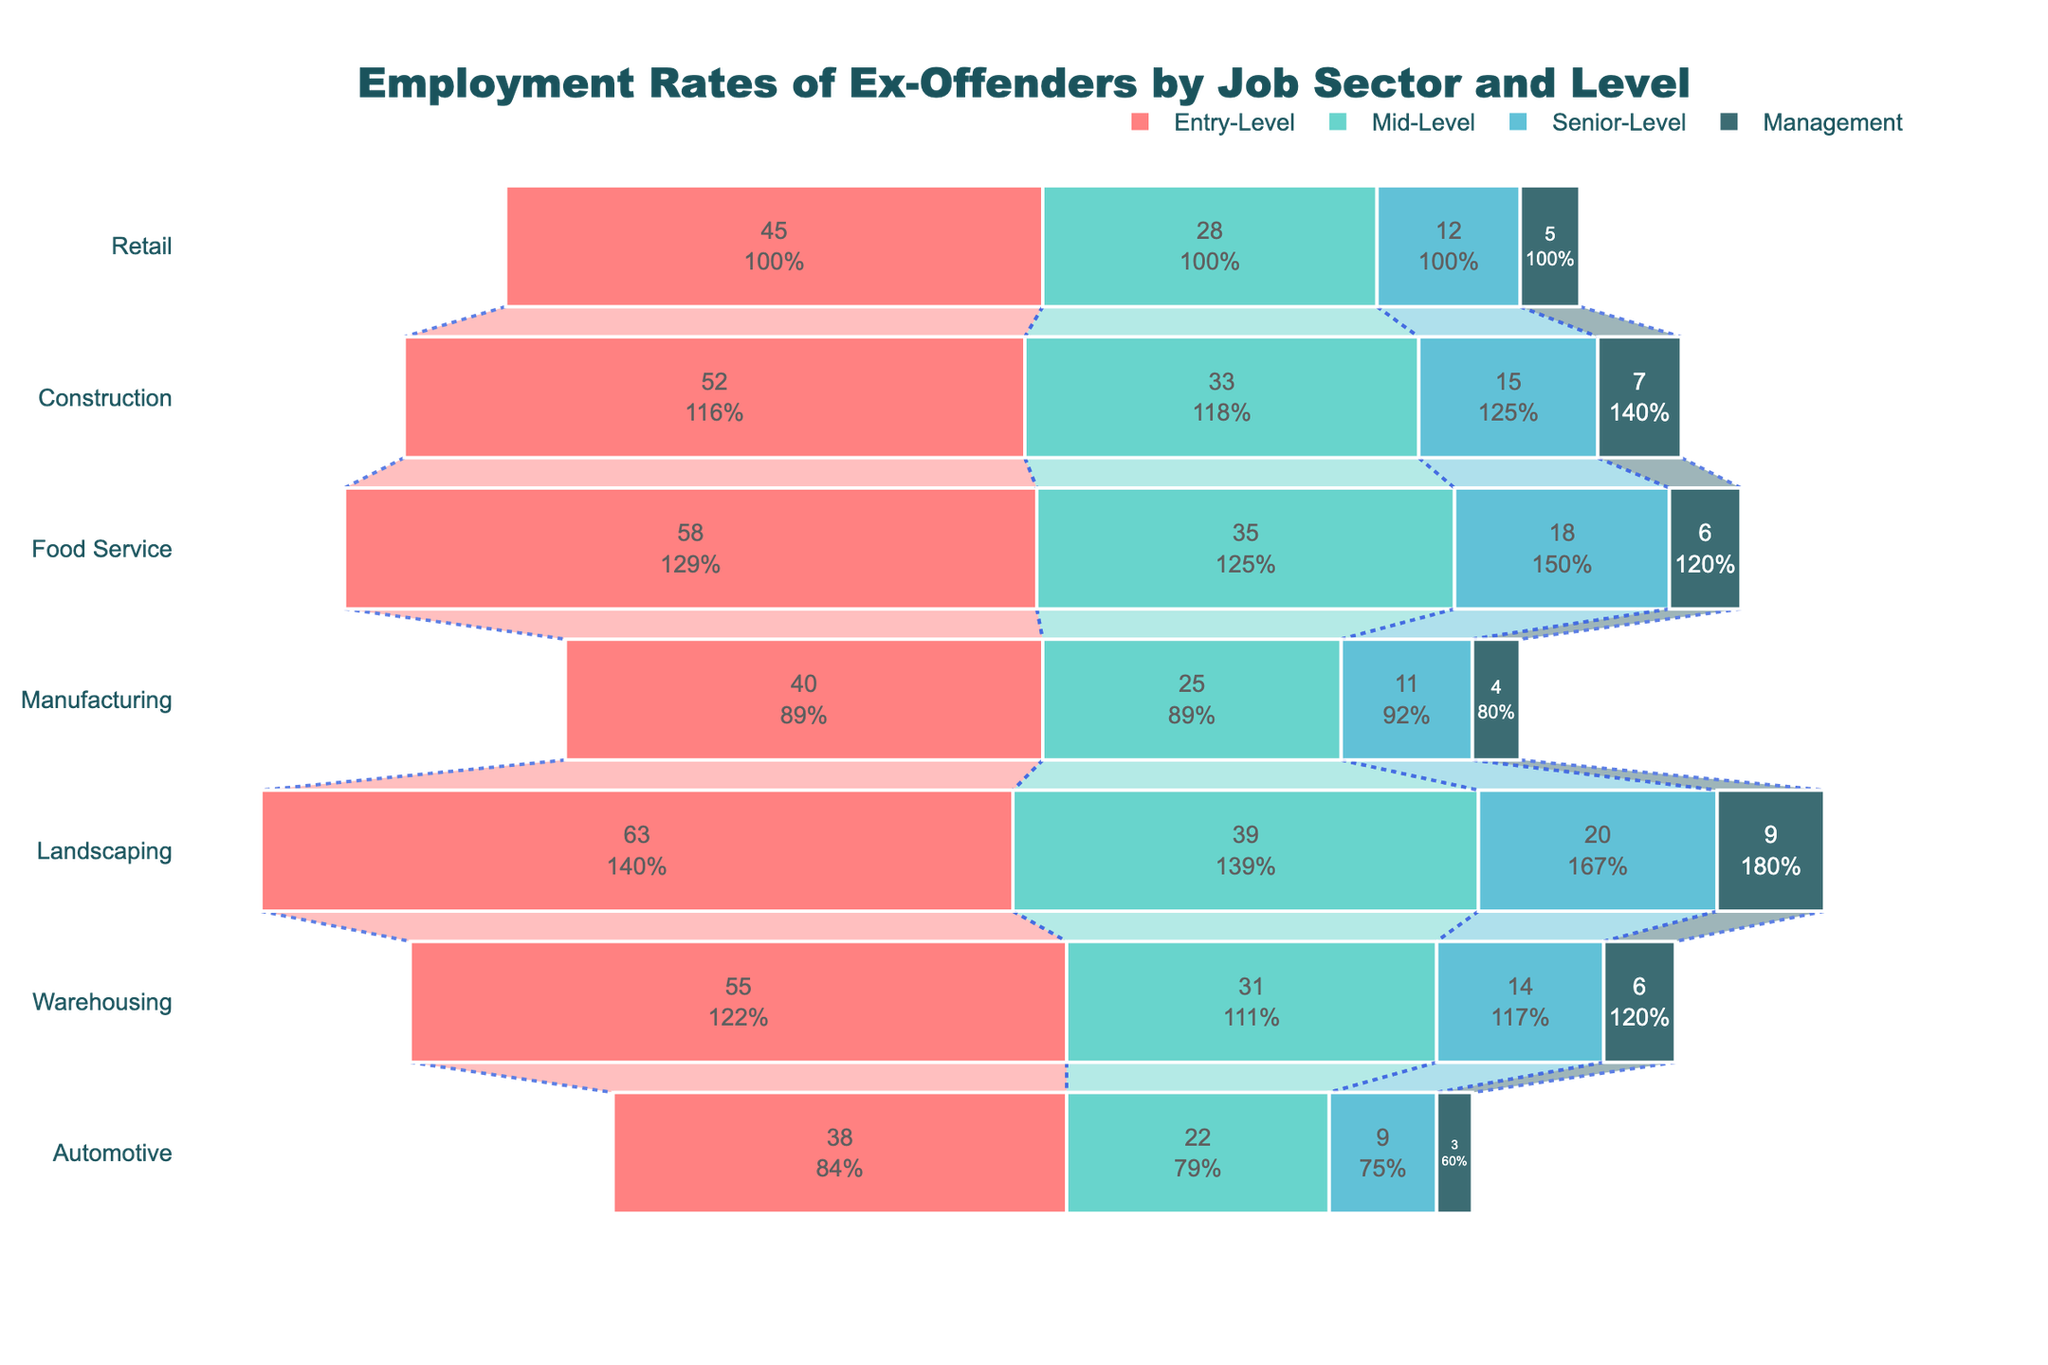What's the title of the figure? The title is typically displayed at the top center of the figure. In this case, the title is "Employment Rates of Ex-Offenders by Job Sector and Level."
Answer: Employment Rates of Ex-Offenders by Job Sector and Level How many job sectors are analyzed in the figure? The job sectors appear on the y-axis of the funnel chart. By counting them, we can see there are seven job sectors listed.
Answer: Seven Which job sector has the highest percentage of ex-offenders at the entry-level? By observing the bars at the "Entry-Level" section, the tallest bar corresponds to "Landscaping," which stands at 63%.
Answer: Landscaping Compare entry-level and management positions in the Warehousing sector. What's the difference in the employment rate of ex-offenders? The entry-level employment rate in the Warehousing sector is 55%, while the management level is 6%. Subtracting these gives 55% - 6% = 49%.
Answer: 49% What is the average employment rate of ex-offenders in mid-level positions across all job sectors? Add the mid-level percentages for each sector: 28% + 33% + 35% + 25% + 39% + 31% + 22% = 213%. Divide by 7 to get the average, 213% / 7 ≈ 30.43%.
Answer: 30.43% Which job sector shows the greatest decline in the employment rate of ex-offenders from entry-level to senior-level positions? We need to calculate the difference for each sector: Retail (45% - 12% = 33%), Construction (52% - 15% = 37%), Food Service (58% - 18% = 40%), Manufacturing (40% - 11% = 29%), Landscaping (63% - 20% = 43%), Warehousing (55% - 14% = 41%), Automotive (38% - 9% = 29%). The largest difference is in Landscaping, with 43%.
Answer: Landscaping Between Retail and Manufacturing sectors, which one has a higher employment rate of ex-offenders in senior-level positions? In the Retail sector, the senior-level employment rate is 12%, and in the Manufacturing sector, it is 11%. 12% is higher than 11%, so Retail has a higher rate.
Answer: Retail Across all sectors, which level generally has the lowest employment rates of ex-offenders? By examining the chart, it's evident that the Management level has the lowest employment rates in all job sectors.
Answer: Management 